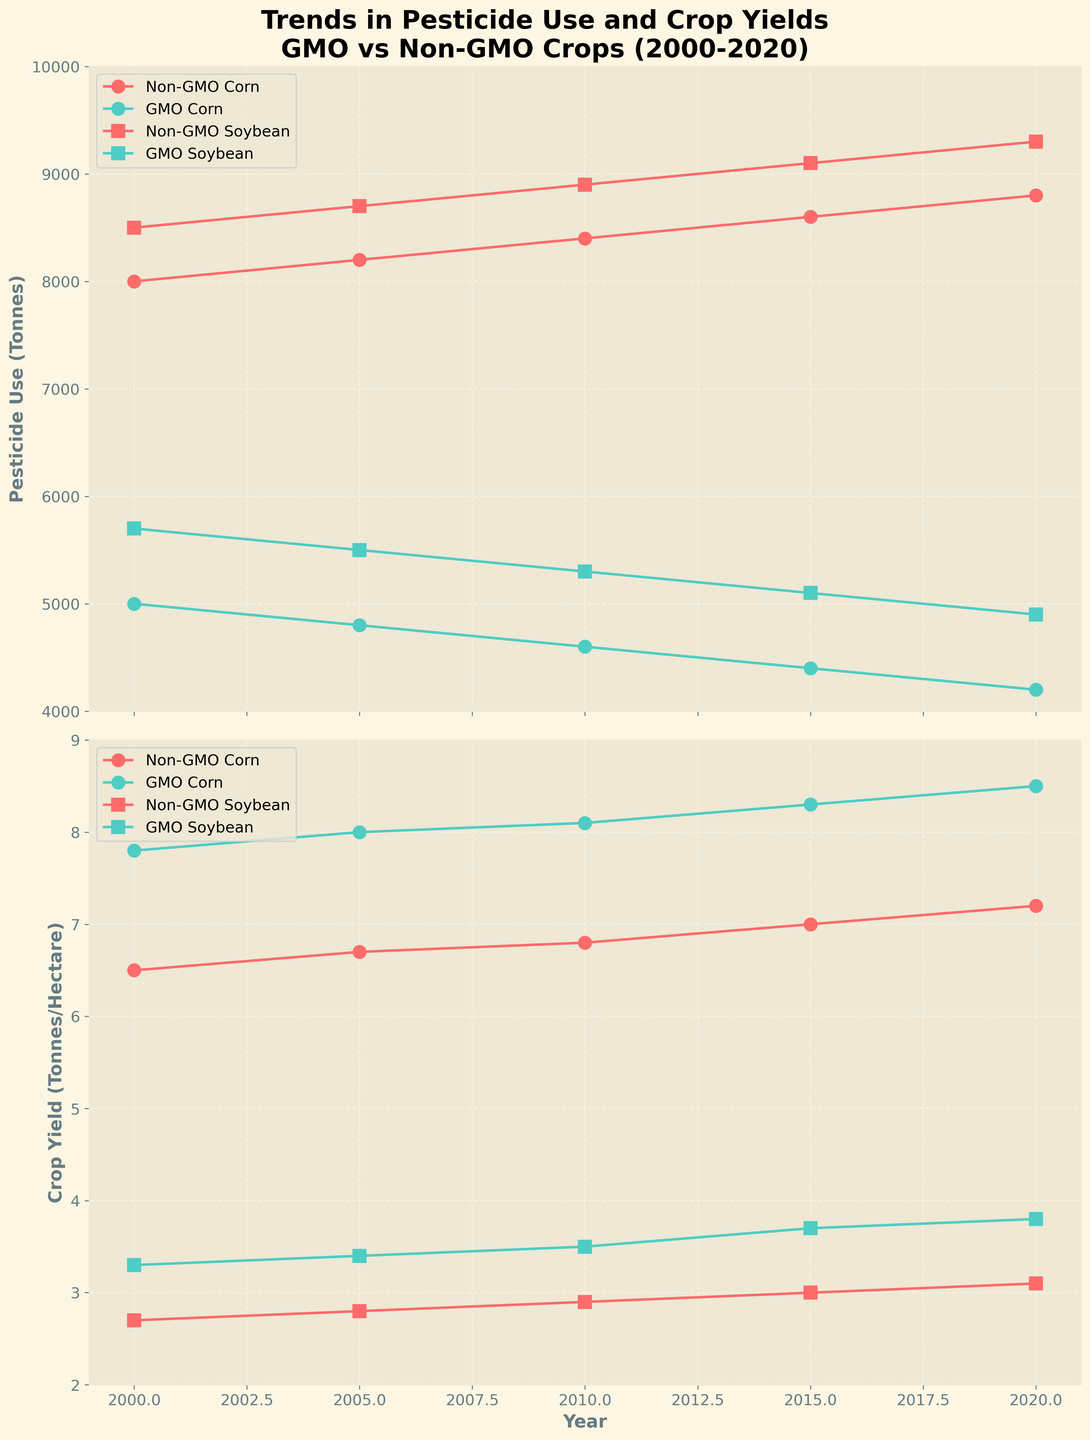What is the title of the figure? The title is usually placed at the top of the figure and changes to emphasize what the plot is about. In this case, the title is clear and descriptive of the content related to pesticide use, crop yields, and comparing GMO vs. Non-GMO crops over time.
Answer: Trends in Pesticide Use and Crop Yields for GMO vs Non-GMO Crops (2000-2020) What are the labels of the y-axes? The labels of the y-axes are usually found next to the axes. In the first plot, it corresponds to pesticide use, and in the second plot, it relates to crop yield.
Answer: Pesticide Use (Tonnes) and Crop Yield (Tonnes/Hectare) Which year shows the highest crop yield for GMO Corn? By following the trend lines for GMO Corn in the crop yield plot, we look for the maximum point. The highest yield for GMO Corn appears in 2020.
Answer: 2020 What is the overall trend in pesticide use for Non-GMO Soybean from 2000 to 2020? Observing the Non-GMO Soybean line in the pesticide use graph, we notice it generally slopes upwards from 8500 to 9300 tonnes, indicating an increase over this period.
Answer: Increasing How does the crop yield for Non-GMO Soybean in 2015 compare to that in 2000? By looking at the crop yield plot for Non-GMO Soybean, we see the yields in 2000 and 2015. In 2000, it is 2.7 tonnes/hectare and in 2015, it is 3.0 tonnes/hectare.
Answer: Higher in 2015 Which crop type has a more significant reduction in pesticide use between 2000 and 2020, GMO Corn or Non-GMO Corn? By noting the starting and ending values for both types in the pesticide use graph, GMO Corn reduces from 5000 to 4200 tonnes, and Non-GMO Corn increases. Therefore, GMO Corn has a reduction while Non-GMO Corn does not.
Answer: GMO Corn What visual elements differentiate the data for Corn and Soybean in the plot? The plot uses different markers for each crop type: circles for Corn and squares for Soybean. This helps distinguish the two crops visually.
Answer: Circles for Corn and squares for Soybean Is there a year where the crop yield for GMO Soybean surpasses 3.5 tonnes per hectare? If so, which year? Inspecting the GMO Soybean line in the crop yield plot, we see it surpasses 3.5 tonnes per hectare from 2010 onwards.
Answer: 2010 What is the trend in crop yield for GMO Corn from 2000 to 2020? The trend line for GMO Corn in the crop yield graph shows a steady increase from 7.8 tonnes/hectare in 2000 to 8.5 tonnes/hectare in 2020.
Answer: Increasing 